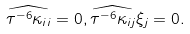Convert formula to latex. <formula><loc_0><loc_0><loc_500><loc_500>\widehat { \tau ^ { - 6 } \kappa _ { i i } } = 0 , \widehat { \tau ^ { - 6 } \kappa _ { i j } } \xi _ { j } = 0 .</formula> 